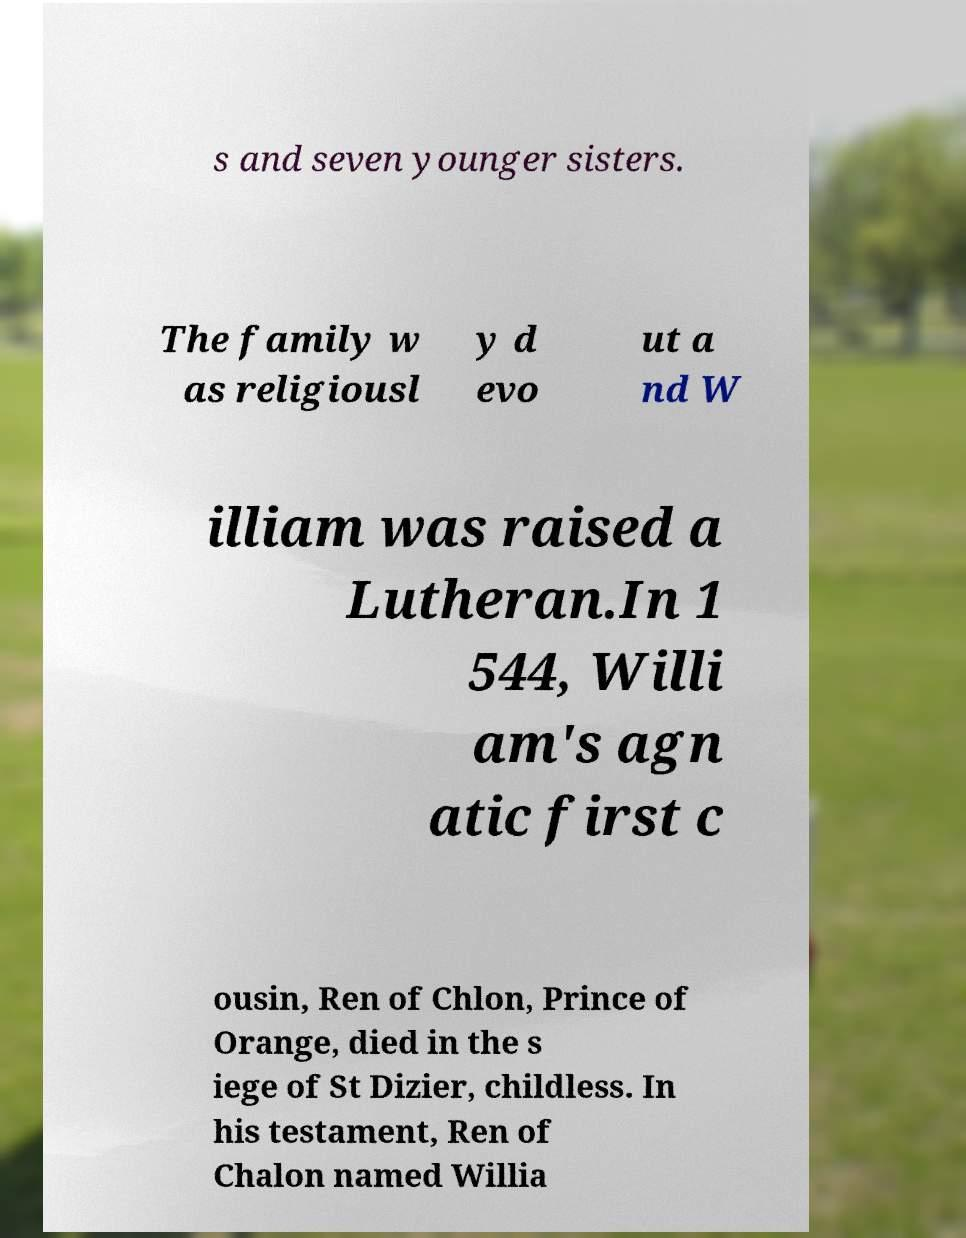What messages or text are displayed in this image? I need them in a readable, typed format. s and seven younger sisters. The family w as religiousl y d evo ut a nd W illiam was raised a Lutheran.In 1 544, Willi am's agn atic first c ousin, Ren of Chlon, Prince of Orange, died in the s iege of St Dizier, childless. In his testament, Ren of Chalon named Willia 